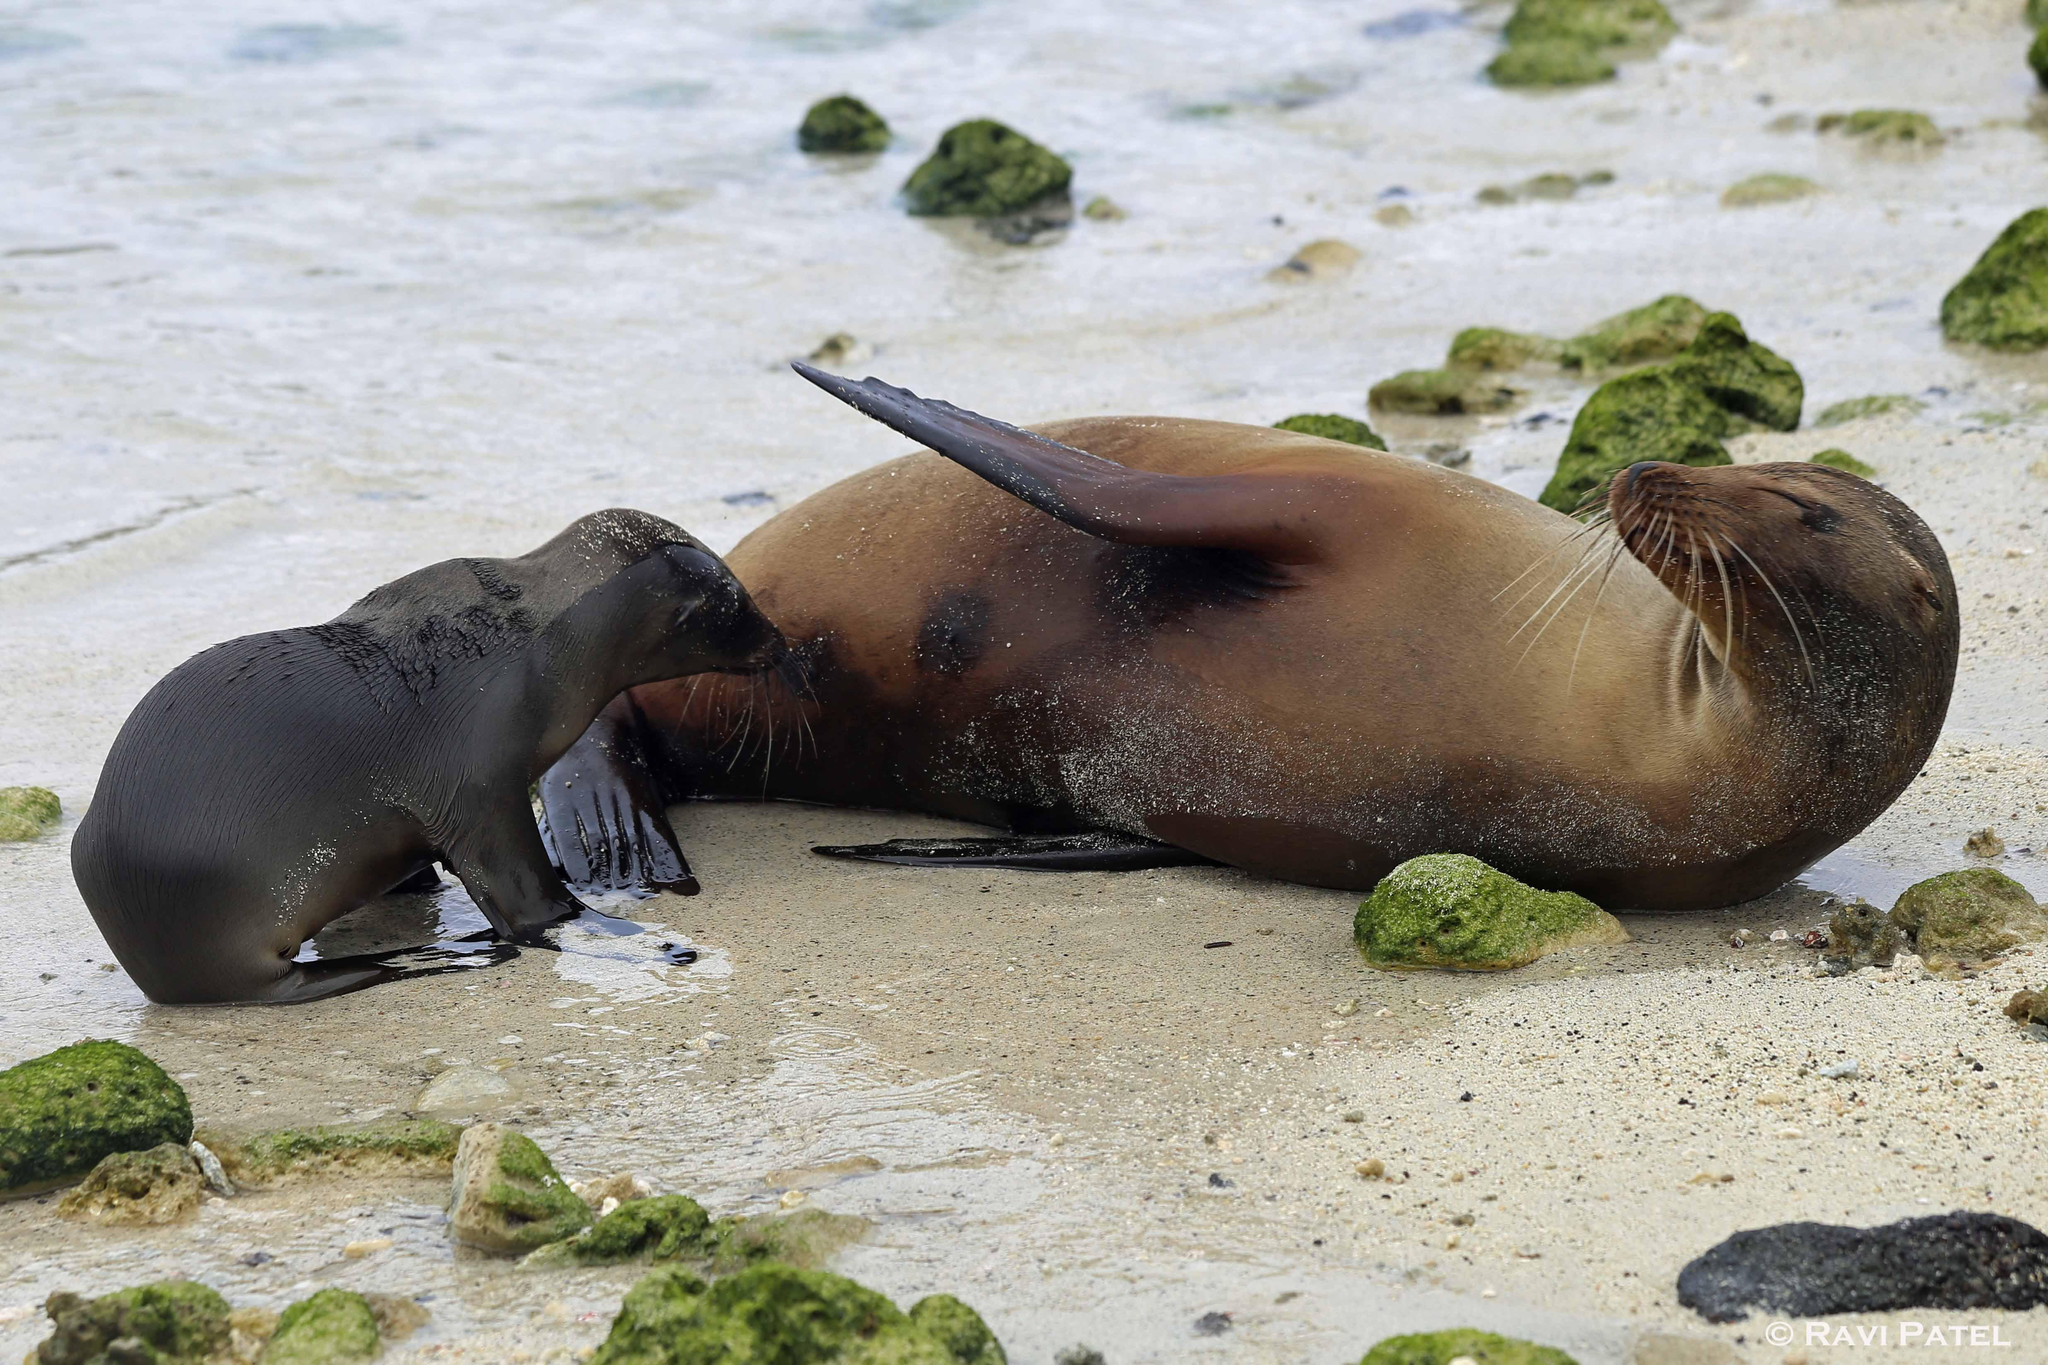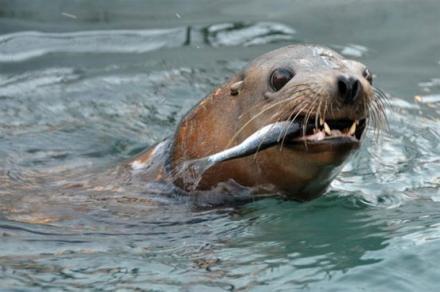The first image is the image on the left, the second image is the image on the right. For the images displayed, is the sentence "The seal in the right image has a fish in it's mouth." factually correct? Answer yes or no. Yes. The first image is the image on the left, the second image is the image on the right. Analyze the images presented: Is the assertion "There is a seal with a fish hanging from the left side of their mouth" valid? Answer yes or no. Yes. 